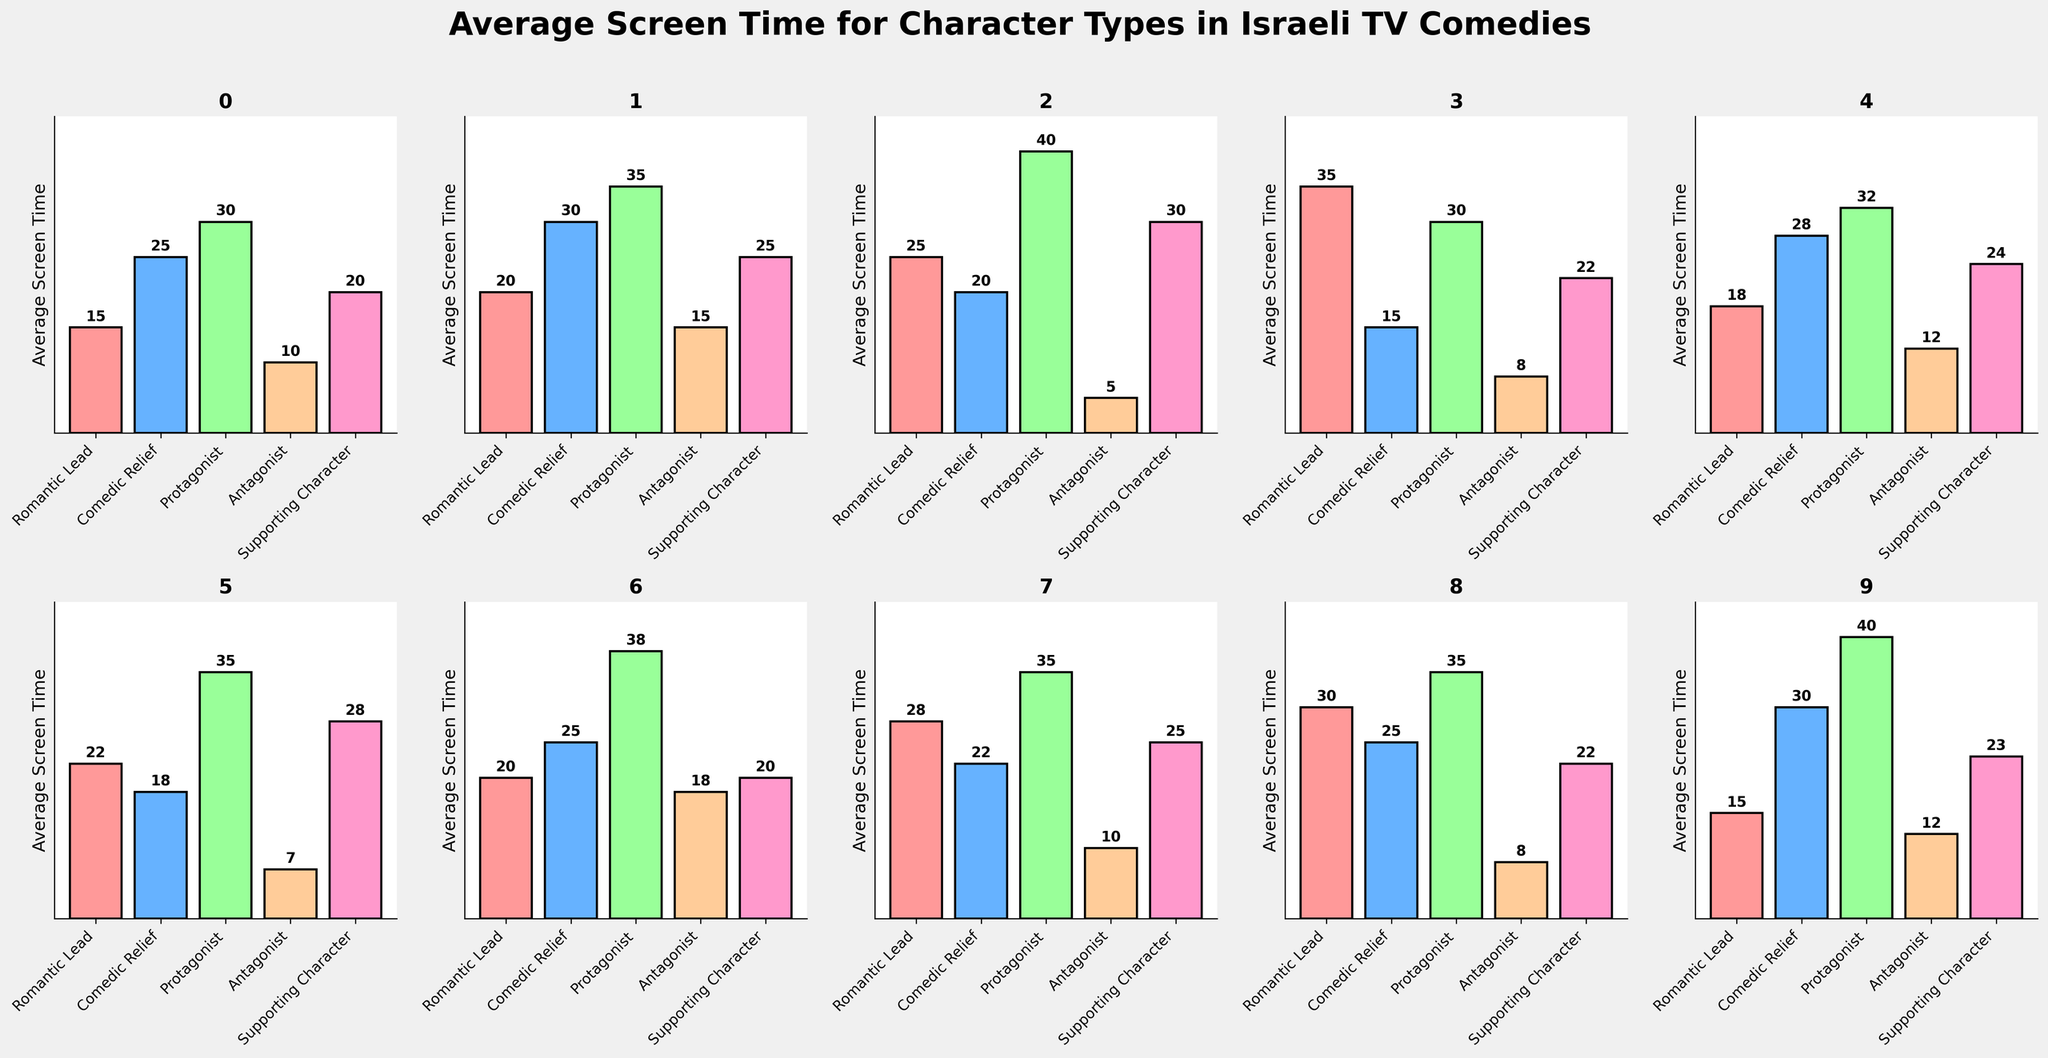Which character type has the highest average screen time in Romantic Comedies? In the subplot for Romantic Comedy, we identify each bar corresponding to different character types. The highest bar represents the Romantic Lead with a value of 35.
Answer: Romantic Lead Which character type has the smallest difference in average screen time between Family Sitcoms and Historical Comedies? Calculate the screen time difference for each character type between Family Sitcom and Historical Comedy: Romantic Lead (25-15=10), Comedic Relief (20-30=10), Protagonist (40-40=0), Antagonist (5-12=7), Supporting Character (30-23=7). The Protagonist shows a 0 difference.
Answer: Protagonist How does the average screen time of the Antagonist in Political Satire compare to Workplace Comedy? Check the subplot for Political Satire and note the Antagonist's screen time (18). Then, do the same for Workplace Comedy (15). Compare: 18 is greater than 15.
Answer: Greater What's the total average screen time for the Comedic Relief character type across all the sitcom types? Sum up the screen time values for Comedic Relief from each subplot: 25 (Drama Sitcom) + 30 (Workplace Comedy) + 20 (Family Sitcom) + 15 (Romantic Comedy) + 28 (Military Comedy) + 18 (Religious Comedy) + 25 (Political Satire) + 22 (Immigrant Comedy) + 25 (Teen Comedy) + 30 (Historical Comedy) = 238.
Answer: 238 Which sitcom type has the tallest bar in any of the subplots, and which character does it represent? Identify the tallest bar across all subplots: The one in Romantic Comedy subplot for Romantic Lead character, which is 35.
Answer: Romantic Comedy, Romantic Lead Which sitcom type has the smallest screen time for its Supporting Character? Locate the bars for Supporting Characters across all subplots. The smallest value is 20 in both Drama Sitcom and Political Satire.
Answer: Drama Sitcom and Political Satire In Drama Sitcom, what is the ratio of the screen time of Protagonist to Antagonist? From the Drama Sitcom subplot, Protagonist has 30, and Antagonist has 10. So the ratio is 30:10, which simplifies to 3:1.
Answer: 3:1 What is the combined screen time of Romantic Lead and Comedic Relief in Religious Comedy? Looking at the subplot for Religious Comedy, sum the values: Romantic Lead (22) + Comedic Relief (18) = 40.
Answer: 40 Which character type is dominant in Military Comedy, and by how much? Identify the highest bar in the Military Comedy subplot. The Protagonist has the highest screen time (32). To find how dominant: compare to the next highest, which is Comedic Relief (28). The difference is 32 - 28 = 4.
Answer: Protagonist, by 4 